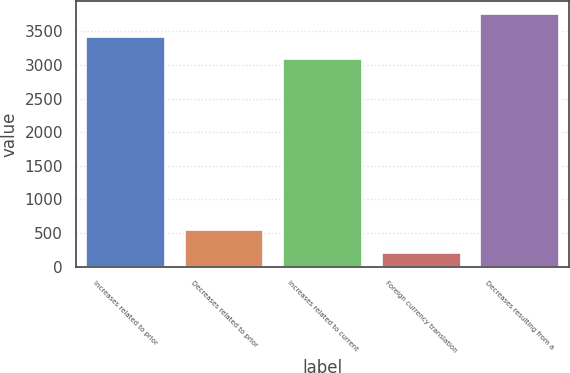Convert chart to OTSL. <chart><loc_0><loc_0><loc_500><loc_500><bar_chart><fcel>Increases related to prior<fcel>Decreases related to prior<fcel>Increases related to current<fcel>Foreign currency translation<fcel>Decreases resulting from a<nl><fcel>3420.5<fcel>538.5<fcel>3083<fcel>201<fcel>3758<nl></chart> 